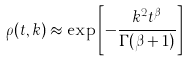<formula> <loc_0><loc_0><loc_500><loc_500>\rho ( t , { k } ) \approx \exp \left [ - \frac { { k } ^ { 2 } t ^ { \beta } } { \Gamma ( \beta + 1 ) } \right ]</formula> 